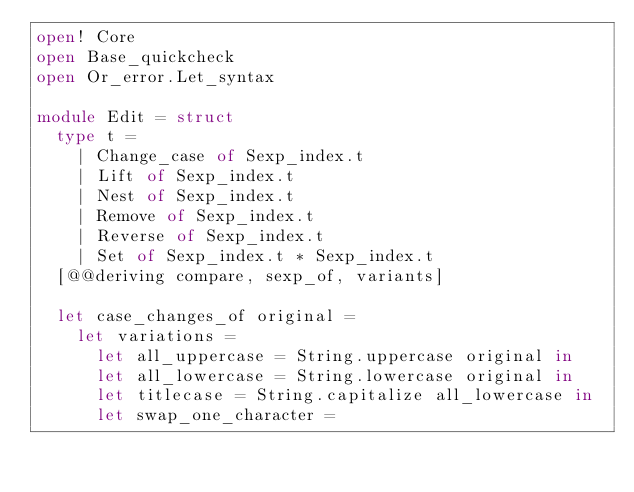<code> <loc_0><loc_0><loc_500><loc_500><_OCaml_>open! Core
open Base_quickcheck
open Or_error.Let_syntax

module Edit = struct
  type t =
    | Change_case of Sexp_index.t
    | Lift of Sexp_index.t
    | Nest of Sexp_index.t
    | Remove of Sexp_index.t
    | Reverse of Sexp_index.t
    | Set of Sexp_index.t * Sexp_index.t
  [@@deriving compare, sexp_of, variants]

  let case_changes_of original =
    let variations =
      let all_uppercase = String.uppercase original in
      let all_lowercase = String.lowercase original in
      let titlecase = String.capitalize all_lowercase in
      let swap_one_character =</code> 